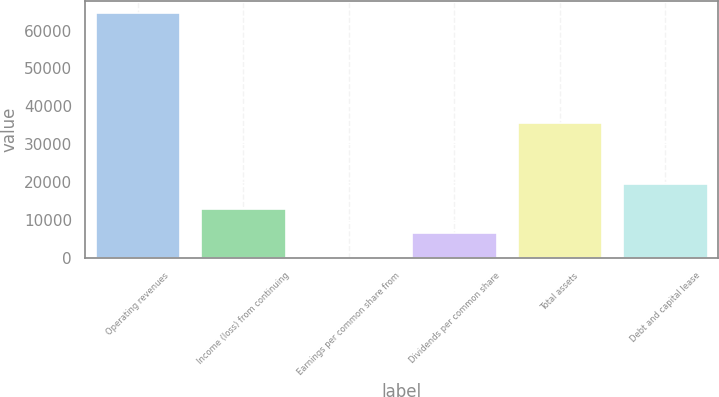Convert chart to OTSL. <chart><loc_0><loc_0><loc_500><loc_500><bar_chart><fcel>Operating revenues<fcel>Income (loss) from continuing<fcel>Earnings per common share from<fcel>Dividends per common share<fcel>Total assets<fcel>Debt and capital lease<nl><fcel>64599<fcel>12920.2<fcel>0.5<fcel>6460.35<fcel>35572<fcel>19380<nl></chart> 